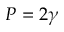<formula> <loc_0><loc_0><loc_500><loc_500>P = 2 \gamma</formula> 